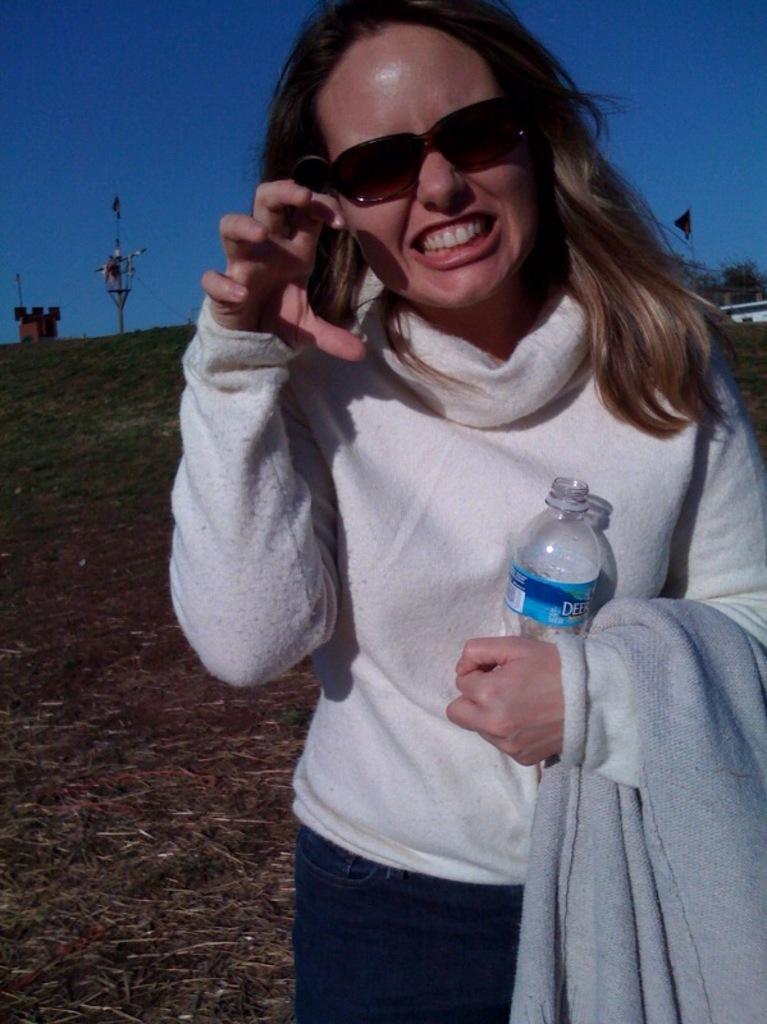How would you summarize this image in a sentence or two? In this image I can see a person standing wearing white shirt, blue pant and holding a bottle. Background I can see few poles, grass in green color and the sky is in blue color. 